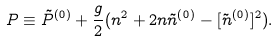Convert formula to latex. <formula><loc_0><loc_0><loc_500><loc_500>P \equiv \tilde { P } ^ { ( 0 ) } + \frac { g } { 2 } ( n ^ { 2 } + 2 n \tilde { n } ^ { ( 0 ) } - [ \tilde { n } ^ { ( 0 ) } ] ^ { 2 } ) . \\</formula> 